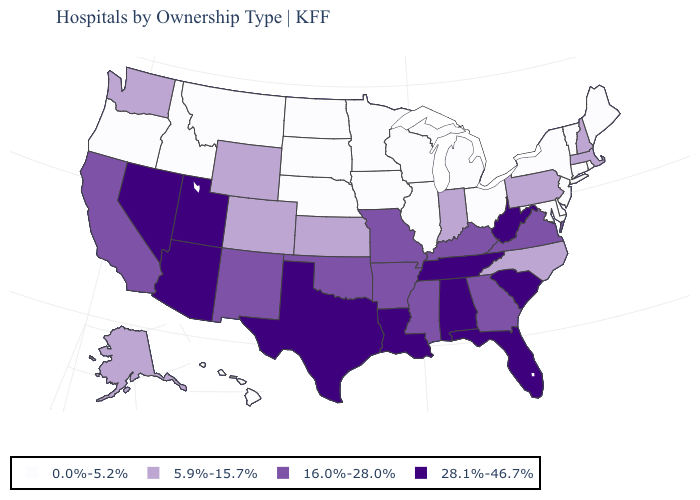What is the value of Delaware?
Short answer required. 0.0%-5.2%. Name the states that have a value in the range 0.0%-5.2%?
Answer briefly. Connecticut, Delaware, Hawaii, Idaho, Illinois, Iowa, Maine, Maryland, Michigan, Minnesota, Montana, Nebraska, New Jersey, New York, North Dakota, Ohio, Oregon, Rhode Island, South Dakota, Vermont, Wisconsin. Is the legend a continuous bar?
Quick response, please. No. What is the value of Montana?
Concise answer only. 0.0%-5.2%. What is the value of New Hampshire?
Answer briefly. 5.9%-15.7%. Does the map have missing data?
Short answer required. No. What is the highest value in the West ?
Be succinct. 28.1%-46.7%. Does Oklahoma have the same value as Alabama?
Answer briefly. No. Which states have the lowest value in the USA?
Keep it brief. Connecticut, Delaware, Hawaii, Idaho, Illinois, Iowa, Maine, Maryland, Michigan, Minnesota, Montana, Nebraska, New Jersey, New York, North Dakota, Ohio, Oregon, Rhode Island, South Dakota, Vermont, Wisconsin. Name the states that have a value in the range 5.9%-15.7%?
Be succinct. Alaska, Colorado, Indiana, Kansas, Massachusetts, New Hampshire, North Carolina, Pennsylvania, Washington, Wyoming. Does Texas have the lowest value in the South?
Keep it brief. No. Among the states that border Nebraska , does Kansas have the highest value?
Be succinct. No. What is the value of Mississippi?
Concise answer only. 16.0%-28.0%. Which states have the lowest value in the USA?
Concise answer only. Connecticut, Delaware, Hawaii, Idaho, Illinois, Iowa, Maine, Maryland, Michigan, Minnesota, Montana, Nebraska, New Jersey, New York, North Dakota, Ohio, Oregon, Rhode Island, South Dakota, Vermont, Wisconsin. 